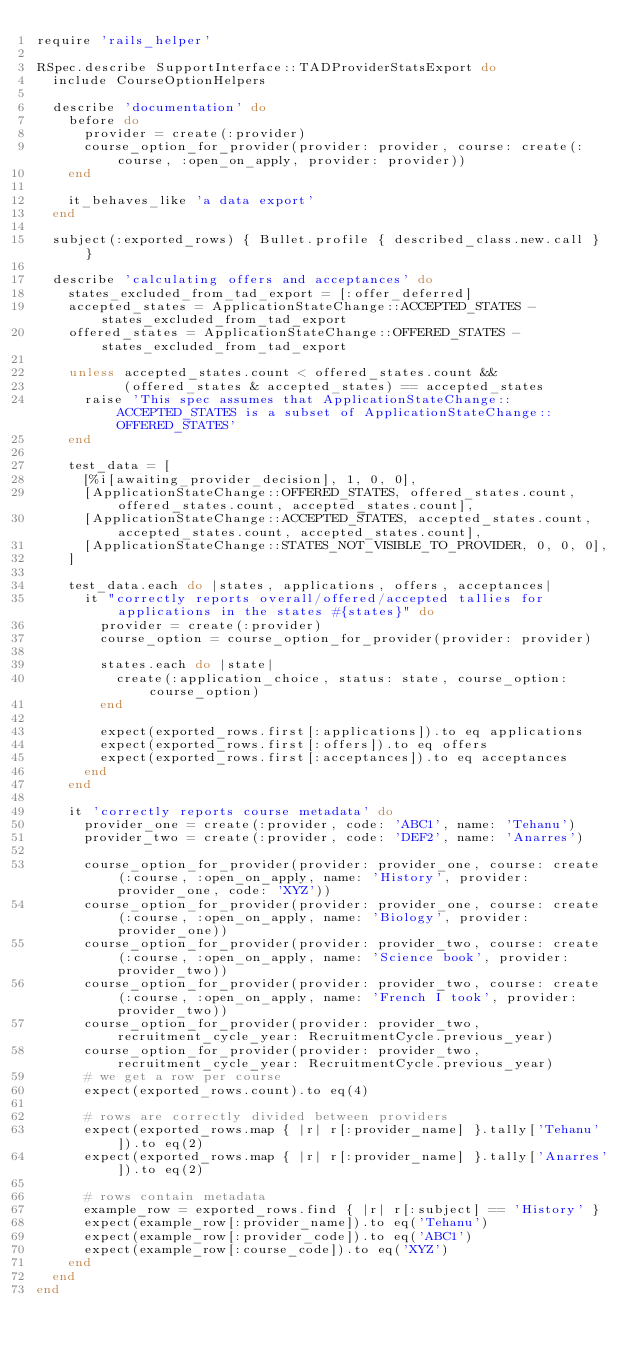Convert code to text. <code><loc_0><loc_0><loc_500><loc_500><_Ruby_>require 'rails_helper'

RSpec.describe SupportInterface::TADProviderStatsExport do
  include CourseOptionHelpers

  describe 'documentation' do
    before do
      provider = create(:provider)
      course_option_for_provider(provider: provider, course: create(:course, :open_on_apply, provider: provider))
    end

    it_behaves_like 'a data export'
  end

  subject(:exported_rows) { Bullet.profile { described_class.new.call } }

  describe 'calculating offers and acceptances' do
    states_excluded_from_tad_export = [:offer_deferred]
    accepted_states = ApplicationStateChange::ACCEPTED_STATES - states_excluded_from_tad_export
    offered_states = ApplicationStateChange::OFFERED_STATES - states_excluded_from_tad_export

    unless accepted_states.count < offered_states.count &&
           (offered_states & accepted_states) == accepted_states
      raise 'This spec assumes that ApplicationStateChange::ACCEPTED_STATES is a subset of ApplicationStateChange::OFFERED_STATES'
    end

    test_data = [
      [%i[awaiting_provider_decision], 1, 0, 0],
      [ApplicationStateChange::OFFERED_STATES, offered_states.count, offered_states.count, accepted_states.count],
      [ApplicationStateChange::ACCEPTED_STATES, accepted_states.count, accepted_states.count, accepted_states.count],
      [ApplicationStateChange::STATES_NOT_VISIBLE_TO_PROVIDER, 0, 0, 0],
    ]

    test_data.each do |states, applications, offers, acceptances|
      it "correctly reports overall/offered/accepted tallies for applications in the states #{states}" do
        provider = create(:provider)
        course_option = course_option_for_provider(provider: provider)

        states.each do |state|
          create(:application_choice, status: state, course_option: course_option)
        end

        expect(exported_rows.first[:applications]).to eq applications
        expect(exported_rows.first[:offers]).to eq offers
        expect(exported_rows.first[:acceptances]).to eq acceptances
      end
    end

    it 'correctly reports course metadata' do
      provider_one = create(:provider, code: 'ABC1', name: 'Tehanu')
      provider_two = create(:provider, code: 'DEF2', name: 'Anarres')

      course_option_for_provider(provider: provider_one, course: create(:course, :open_on_apply, name: 'History', provider: provider_one, code: 'XYZ'))
      course_option_for_provider(provider: provider_one, course: create(:course, :open_on_apply, name: 'Biology', provider: provider_one))
      course_option_for_provider(provider: provider_two, course: create(:course, :open_on_apply, name: 'Science book', provider: provider_two))
      course_option_for_provider(provider: provider_two, course: create(:course, :open_on_apply, name: 'French I took', provider: provider_two))
      course_option_for_provider(provider: provider_two, recruitment_cycle_year: RecruitmentCycle.previous_year)
      course_option_for_provider(provider: provider_two, recruitment_cycle_year: RecruitmentCycle.previous_year)
      # we get a row per course
      expect(exported_rows.count).to eq(4)

      # rows are correctly divided between providers
      expect(exported_rows.map { |r| r[:provider_name] }.tally['Tehanu']).to eq(2)
      expect(exported_rows.map { |r| r[:provider_name] }.tally['Anarres']).to eq(2)

      # rows contain metadata
      example_row = exported_rows.find { |r| r[:subject] == 'History' }
      expect(example_row[:provider_name]).to eq('Tehanu')
      expect(example_row[:provider_code]).to eq('ABC1')
      expect(example_row[:course_code]).to eq('XYZ')
    end
  end
end
</code> 